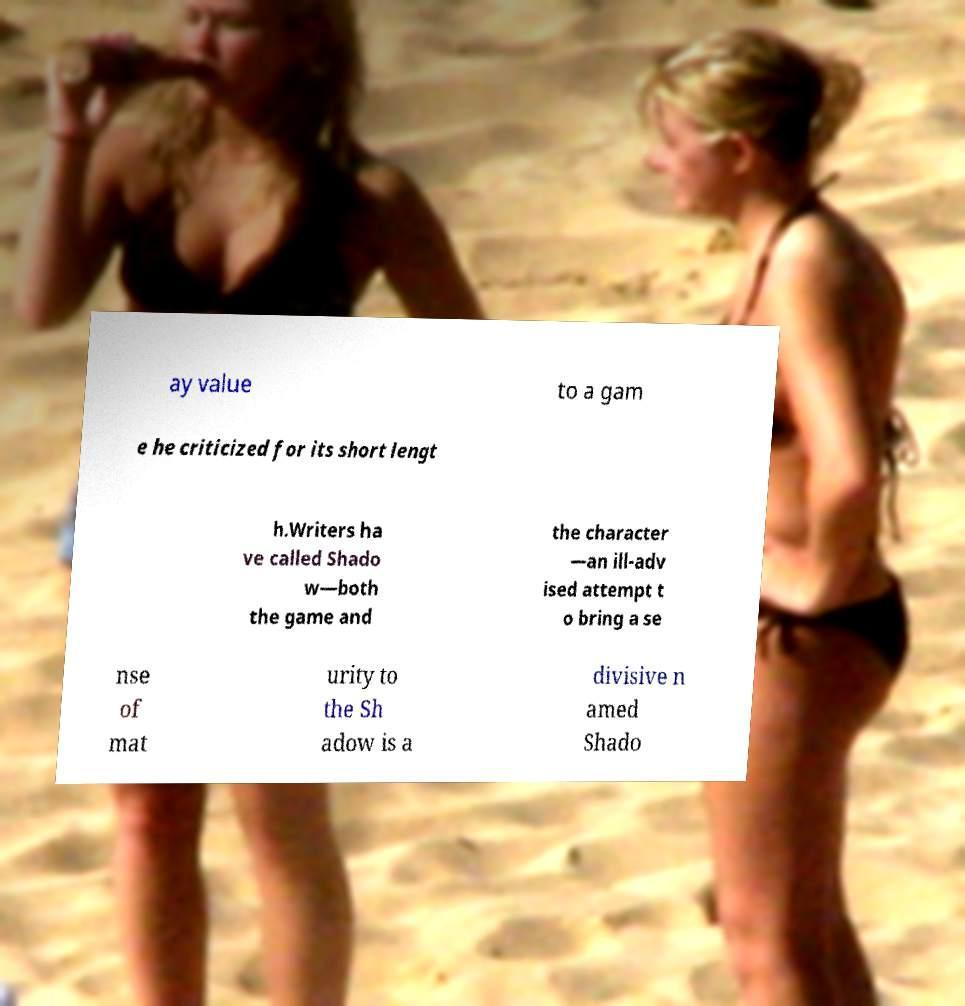Please read and relay the text visible in this image. What does it say? ay value to a gam e he criticized for its short lengt h.Writers ha ve called Shado w—both the game and the character —an ill-adv ised attempt t o bring a se nse of mat urity to the Sh adow is a divisive n amed Shado 